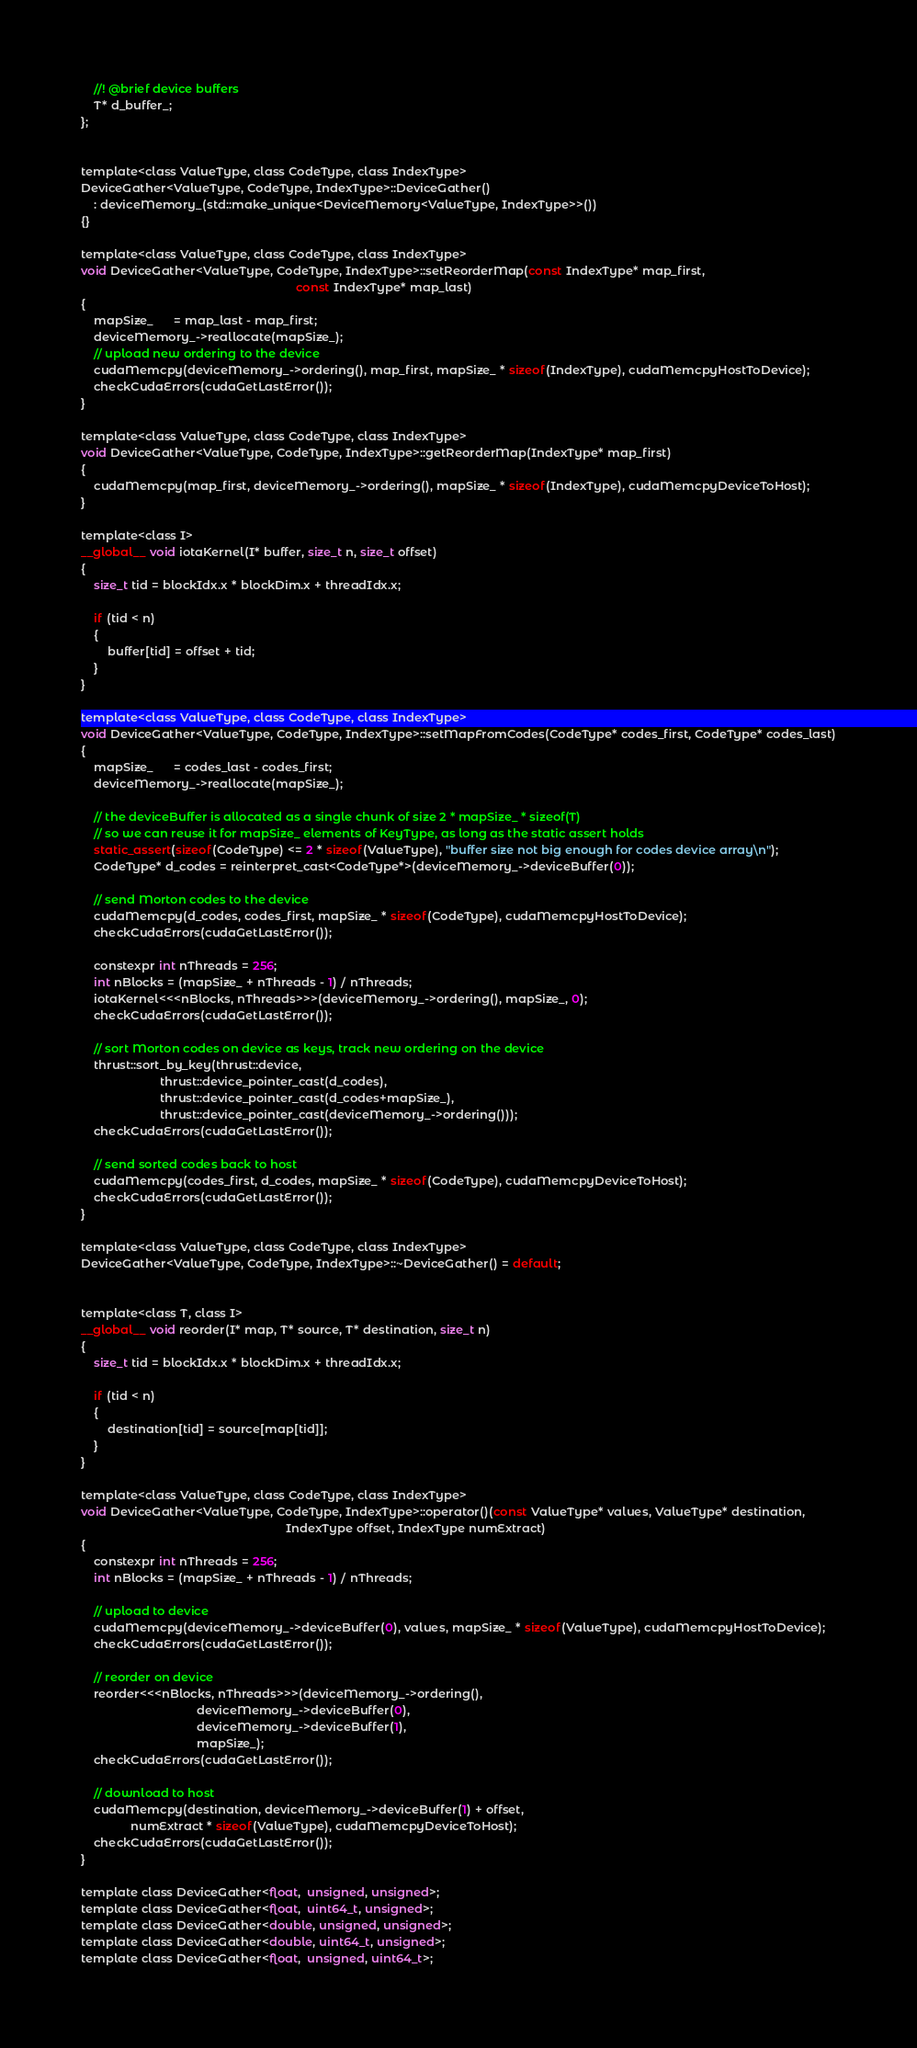<code> <loc_0><loc_0><loc_500><loc_500><_Cuda_>    //! @brief device buffers
    T* d_buffer_;
};


template<class ValueType, class CodeType, class IndexType>
DeviceGather<ValueType, CodeType, IndexType>::DeviceGather()
    : deviceMemory_(std::make_unique<DeviceMemory<ValueType, IndexType>>())
{}

template<class ValueType, class CodeType, class IndexType>
void DeviceGather<ValueType, CodeType, IndexType>::setReorderMap(const IndexType* map_first,
                                                                 const IndexType* map_last)
{
    mapSize_      = map_last - map_first;
    deviceMemory_->reallocate(mapSize_);
    // upload new ordering to the device
    cudaMemcpy(deviceMemory_->ordering(), map_first, mapSize_ * sizeof(IndexType), cudaMemcpyHostToDevice);
    checkCudaErrors(cudaGetLastError());
}

template<class ValueType, class CodeType, class IndexType>
void DeviceGather<ValueType, CodeType, IndexType>::getReorderMap(IndexType* map_first)
{
    cudaMemcpy(map_first, deviceMemory_->ordering(), mapSize_ * sizeof(IndexType), cudaMemcpyDeviceToHost);
}

template<class I>
__global__ void iotaKernel(I* buffer, size_t n, size_t offset)
{
    size_t tid = blockIdx.x * blockDim.x + threadIdx.x;

    if (tid < n)
    {
        buffer[tid] = offset + tid;
    }
}

template<class ValueType, class CodeType, class IndexType>
void DeviceGather<ValueType, CodeType, IndexType>::setMapFromCodes(CodeType* codes_first, CodeType* codes_last)
{
    mapSize_      = codes_last - codes_first;
    deviceMemory_->reallocate(mapSize_);

    // the deviceBuffer is allocated as a single chunk of size 2 * mapSize_ * sizeof(T)
    // so we can reuse it for mapSize_ elements of KeyType, as long as the static assert holds
    static_assert(sizeof(CodeType) <= 2 * sizeof(ValueType), "buffer size not big enough for codes device array\n");
    CodeType* d_codes = reinterpret_cast<CodeType*>(deviceMemory_->deviceBuffer(0));

    // send Morton codes to the device
    cudaMemcpy(d_codes, codes_first, mapSize_ * sizeof(CodeType), cudaMemcpyHostToDevice);
    checkCudaErrors(cudaGetLastError());

    constexpr int nThreads = 256;
    int nBlocks = (mapSize_ + nThreads - 1) / nThreads;
    iotaKernel<<<nBlocks, nThreads>>>(deviceMemory_->ordering(), mapSize_, 0);
    checkCudaErrors(cudaGetLastError());

    // sort Morton codes on device as keys, track new ordering on the device
    thrust::sort_by_key(thrust::device,
                        thrust::device_pointer_cast(d_codes),
                        thrust::device_pointer_cast(d_codes+mapSize_),
                        thrust::device_pointer_cast(deviceMemory_->ordering()));
    checkCudaErrors(cudaGetLastError());

    // send sorted codes back to host
    cudaMemcpy(codes_first, d_codes, mapSize_ * sizeof(CodeType), cudaMemcpyDeviceToHost);
    checkCudaErrors(cudaGetLastError());
}

template<class ValueType, class CodeType, class IndexType>
DeviceGather<ValueType, CodeType, IndexType>::~DeviceGather() = default;


template<class T, class I>
__global__ void reorder(I* map, T* source, T* destination, size_t n)
{
    size_t tid = blockIdx.x * blockDim.x + threadIdx.x;

    if (tid < n)
    {
        destination[tid] = source[map[tid]];
    }
}

template<class ValueType, class CodeType, class IndexType>
void DeviceGather<ValueType, CodeType, IndexType>::operator()(const ValueType* values, ValueType* destination,
                                                              IndexType offset, IndexType numExtract)
{
    constexpr int nThreads = 256;
    int nBlocks = (mapSize_ + nThreads - 1) / nThreads;

    // upload to device
    cudaMemcpy(deviceMemory_->deviceBuffer(0), values, mapSize_ * sizeof(ValueType), cudaMemcpyHostToDevice);
    checkCudaErrors(cudaGetLastError());

    // reorder on device
    reorder<<<nBlocks, nThreads>>>(deviceMemory_->ordering(),
                                   deviceMemory_->deviceBuffer(0),
                                   deviceMemory_->deviceBuffer(1),
                                   mapSize_);
    checkCudaErrors(cudaGetLastError());

    // download to host
    cudaMemcpy(destination, deviceMemory_->deviceBuffer(1) + offset,
               numExtract * sizeof(ValueType), cudaMemcpyDeviceToHost);
    checkCudaErrors(cudaGetLastError());
}

template class DeviceGather<float,  unsigned, unsigned>;
template class DeviceGather<float,  uint64_t, unsigned>;
template class DeviceGather<double, unsigned, unsigned>;
template class DeviceGather<double, uint64_t, unsigned>;
template class DeviceGather<float,  unsigned, uint64_t>;</code> 